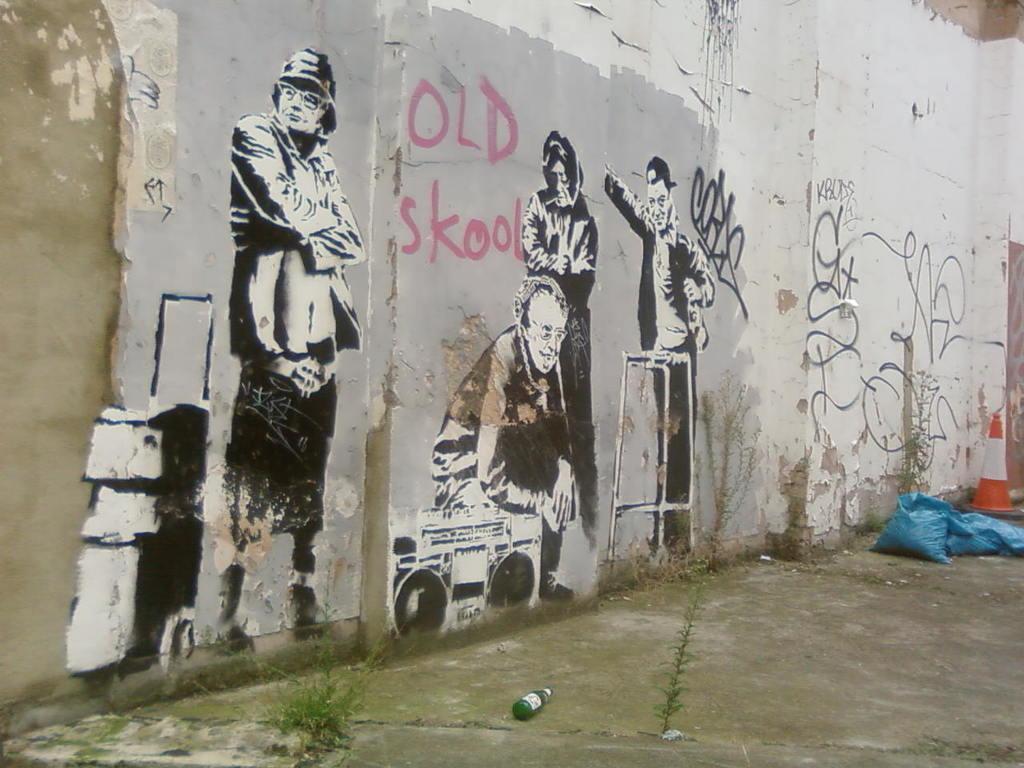Could you give a brief overview of what you see in this image? In this image I can see the ground, a bottle, few plastic bags and a traffic pole. I can see a huge wall and some painting of few persons on the wall. 